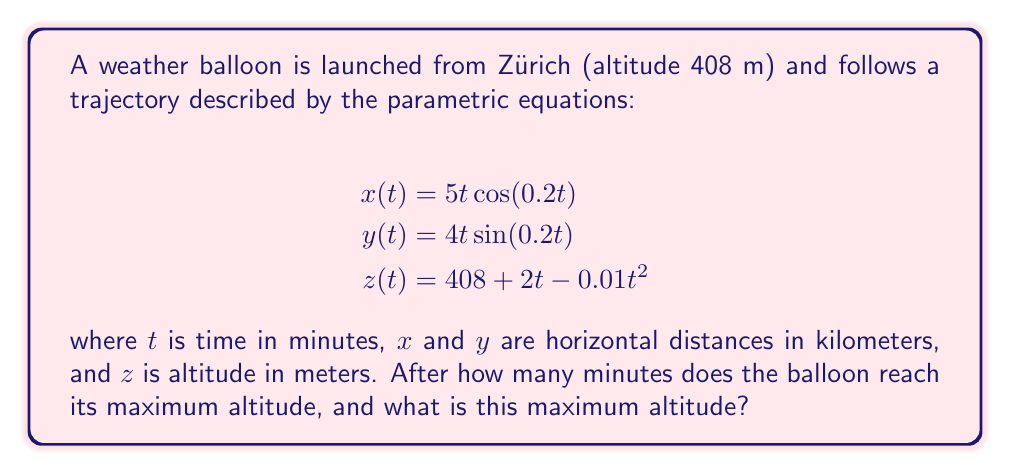Could you help me with this problem? To solve this problem, we need to follow these steps:

1) The maximum altitude occurs when $\frac{dz}{dt} = 0$. Let's find this:

   $$z(t) = 408 + 2t - 0.01t^2$$
   $$\frac{dz}{dt} = 2 - 0.02t$$

2) Set this equal to zero and solve for $t$:

   $$2 - 0.02t = 0$$
   $$-0.02t = -2$$
   $$t = 100$$

3) This means the balloon reaches its maximum altitude after 100 minutes.

4) To find the maximum altitude, we substitute $t = 100$ into the equation for $z(t)$:

   $$z(100) = 408 + 2(100) - 0.01(100)^2$$
   $$= 408 + 200 - 100$$
   $$= 508$$

Therefore, the maximum altitude is 508 meters.

5) We can verify this is a maximum (not a minimum) by checking the second derivative:

   $$\frac{d^2z}{dt^2} = -0.02$$

   This is negative, confirming we've found a maximum.
Answer: The balloon reaches its maximum altitude after 100 minutes, and the maximum altitude is 508 meters. 